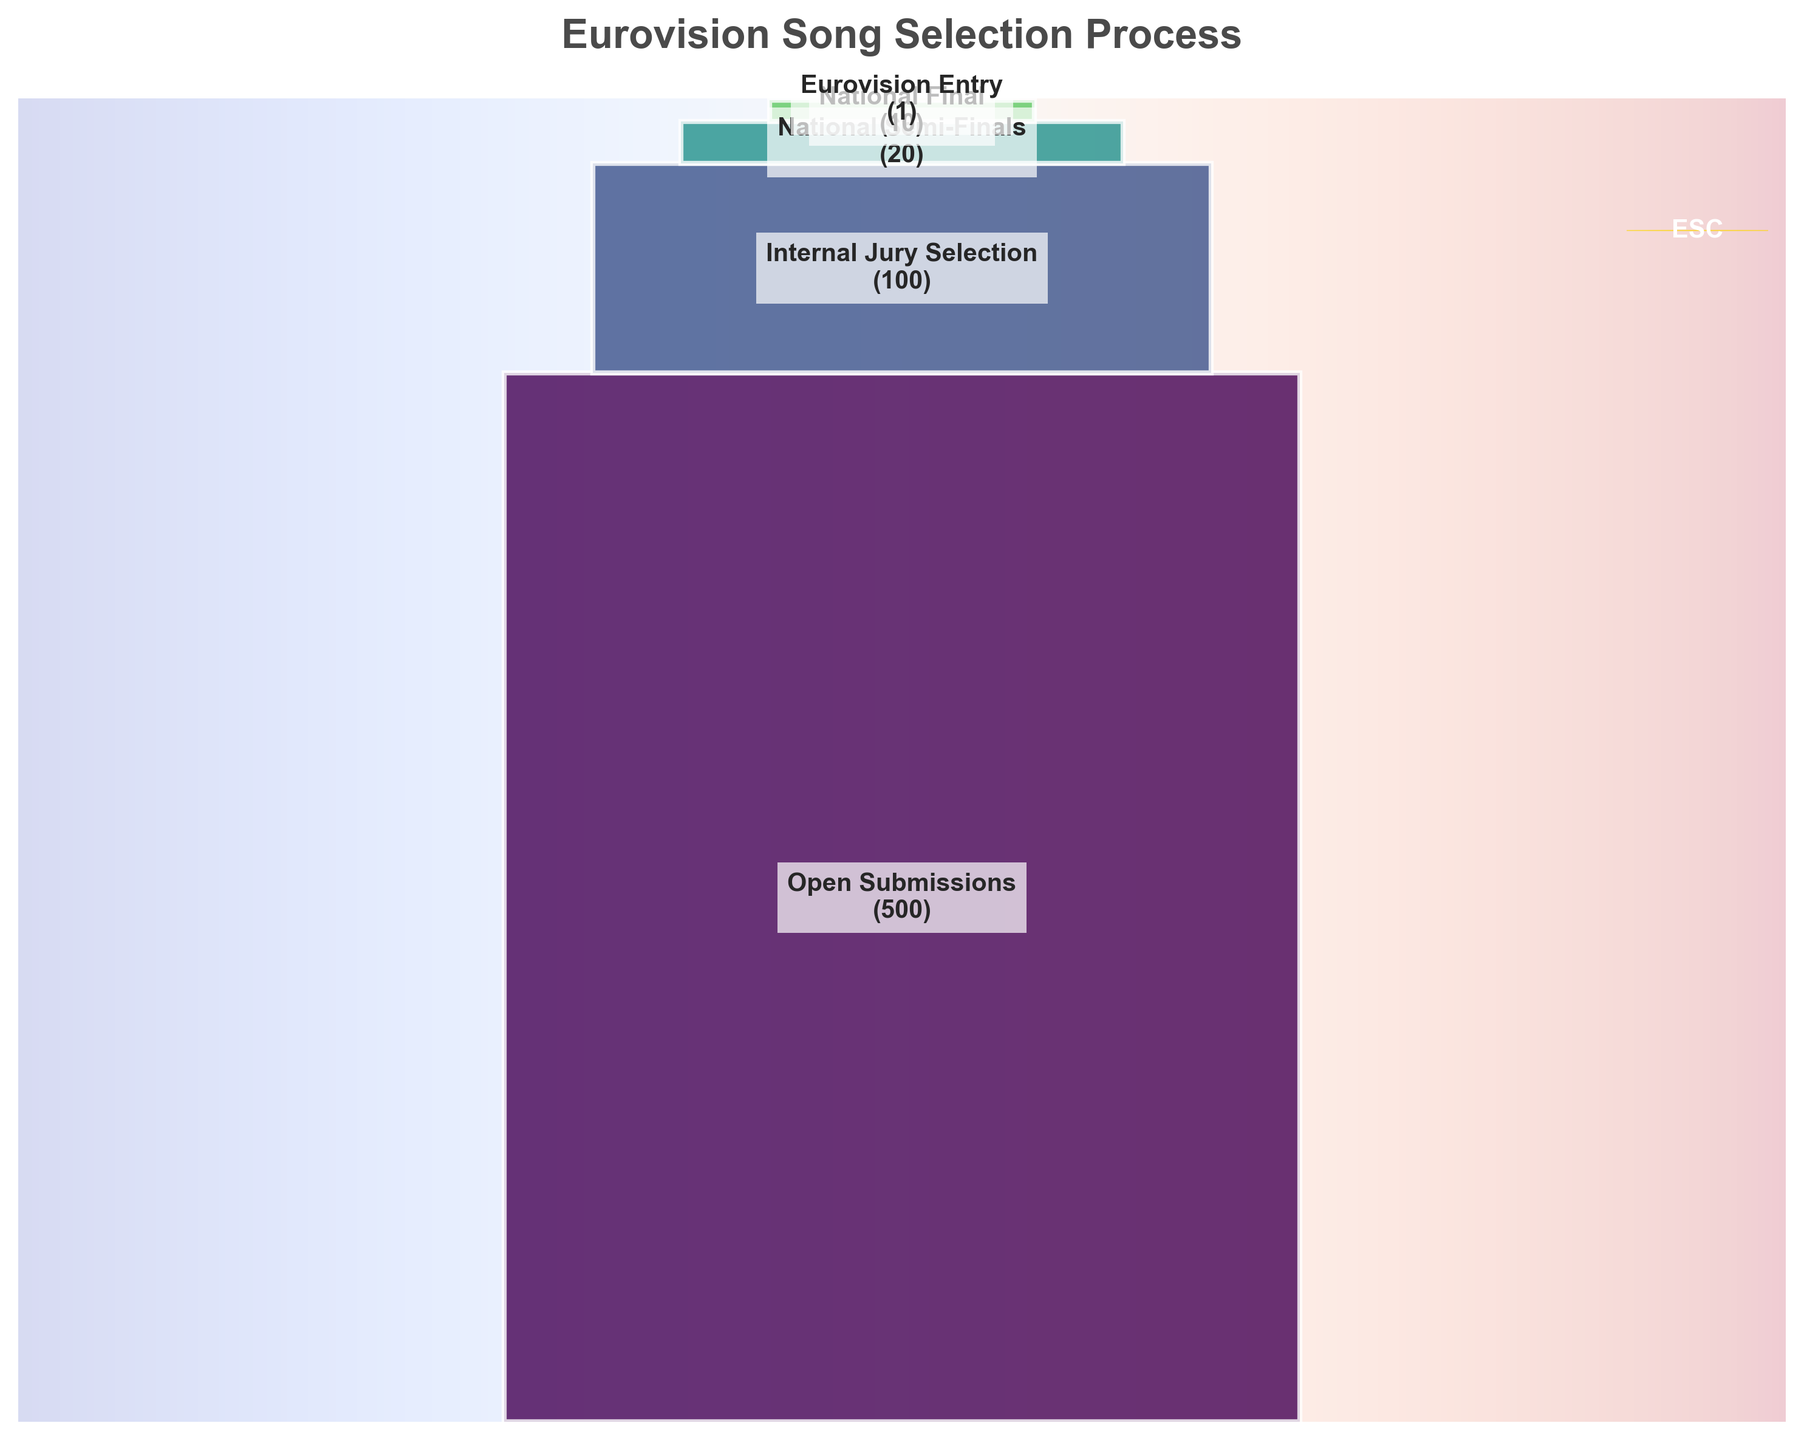What is the title of the figure? The title is usually placed at the top of the figure. It summarizes the content being visualized. The title is "Eurovision Song Selection Process".
Answer: Eurovision Song Selection Process How many stages are represented in the funnel chart? The funnel chart lists different stages, each with a label and number of entries. There are five stages displayed in order.
Answer: Five What is the number of entries at the "National Semi-Finals" stage? By looking at the funnel chart, we find the "National Semi-Finals" stage. The number of entries listed there is 20.
Answer: 20 How do the number of entries from the "Open Submissions" stage compare to the "Eurovision Entry" stage? The "Open Submissions" stage has 500 entries, while the "Eurovision Entry" stage has 1 entry. The first stage has significantly more entries than the final stage.
Answer: 500 vs. 1 How many entries are eliminated between the "National Semi-Finals" and the "Eurovision Entry" stages? To find out how many entries are eliminated, subtract the number of entries at "Eurovision Entry" from those at "National Semi-Finals". This is 20 - 1.
Answer: 19 What stage has the second highest number of entries, and what is that number? By looking at the funnel chart, "Internal Jury Selection" is the stage with the second highest number of entries, which is 100.
Answer: Internal Jury Selection, 100 What is the combined number of entries for the "Internal Jury Selection" and "National Final" stages? Adding the entries from "Internal Jury Selection" (100) and "National Final" (10) gives a combined total of 110.
Answer: 110 Estimate the proportional drop in entries from "Open Submissions" to "Internal Jury Selection". Calculate the proportion by dividing the entries at "Internal Jury Selection" (100) by those at "Open Submissions" (500), then subtract the result from 1. (500 - 100) / 500 = 0.8 or 80%.
Answer: 80% Which stage experiences the largest absolute drop in the number of entries? Calculate the differences between all sequential stages: 500 to 100 (400), 100 to 20 (80), 20 to 10 (10), and 10 to 1 (9). The largest drop is from "Open Submissions" to "Internal Jury Selection" with 400 entries.
Answer: Open Submissions to Internal Jury Selection What is the width of the sections at the "National Semi-Finals"? The figure visually shows varying widths for each stage. The "National Semi-Finals" section appears to be 0.5 units wide based on the width calculations provided for the funnel chart.
Answer: 0.5 